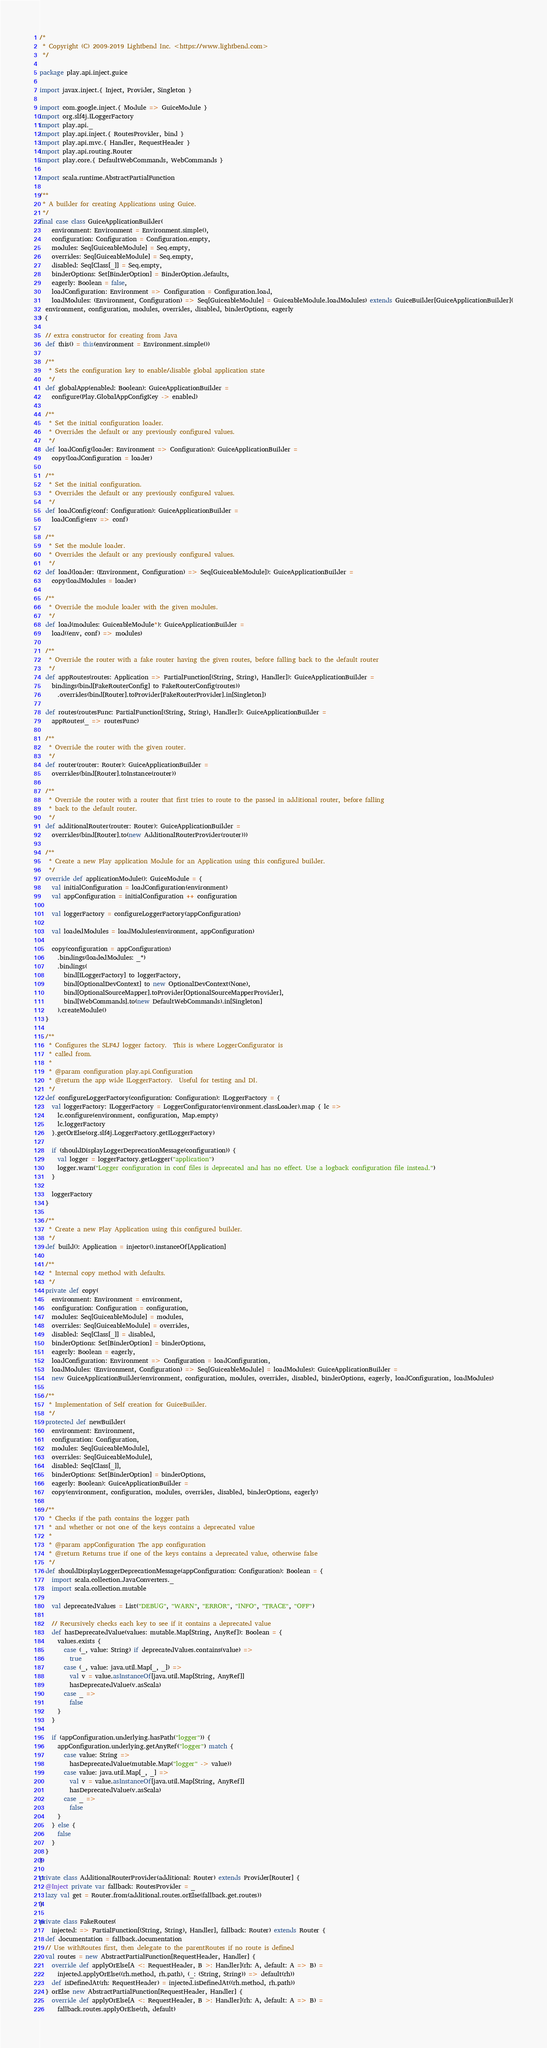Convert code to text. <code><loc_0><loc_0><loc_500><loc_500><_Scala_>/*
 * Copyright (C) 2009-2019 Lightbend Inc. <https://www.lightbend.com>
 */

package play.api.inject.guice

import javax.inject.{ Inject, Provider, Singleton }

import com.google.inject.{ Module => GuiceModule }
import org.slf4j.ILoggerFactory
import play.api._
import play.api.inject.{ RoutesProvider, bind }
import play.api.mvc.{ Handler, RequestHeader }
import play.api.routing.Router
import play.core.{ DefaultWebCommands, WebCommands }

import scala.runtime.AbstractPartialFunction

/**
 * A builder for creating Applications using Guice.
 */
final case class GuiceApplicationBuilder(
    environment: Environment = Environment.simple(),
    configuration: Configuration = Configuration.empty,
    modules: Seq[GuiceableModule] = Seq.empty,
    overrides: Seq[GuiceableModule] = Seq.empty,
    disabled: Seq[Class[_]] = Seq.empty,
    binderOptions: Set[BinderOption] = BinderOption.defaults,
    eagerly: Boolean = false,
    loadConfiguration: Environment => Configuration = Configuration.load,
    loadModules: (Environment, Configuration) => Seq[GuiceableModule] = GuiceableModule.loadModules) extends GuiceBuilder[GuiceApplicationBuilder](
  environment, configuration, modules, overrides, disabled, binderOptions, eagerly
) {

  // extra constructor for creating from Java
  def this() = this(environment = Environment.simple())

  /**
   * Sets the configuration key to enable/disable global application state
   */
  def globalApp(enabled: Boolean): GuiceApplicationBuilder =
    configure(Play.GlobalAppConfigKey -> enabled)

  /**
   * Set the initial configuration loader.
   * Overrides the default or any previously configured values.
   */
  def loadConfig(loader: Environment => Configuration): GuiceApplicationBuilder =
    copy(loadConfiguration = loader)

  /**
   * Set the initial configuration.
   * Overrides the default or any previously configured values.
   */
  def loadConfig(conf: Configuration): GuiceApplicationBuilder =
    loadConfig(env => conf)

  /**
   * Set the module loader.
   * Overrides the default or any previously configured values.
   */
  def load(loader: (Environment, Configuration) => Seq[GuiceableModule]): GuiceApplicationBuilder =
    copy(loadModules = loader)

  /**
   * Override the module loader with the given modules.
   */
  def load(modules: GuiceableModule*): GuiceApplicationBuilder =
    load((env, conf) => modules)

  /**
   * Override the router with a fake router having the given routes, before falling back to the default router
   */
  def appRoutes(routes: Application => PartialFunction[(String, String), Handler]): GuiceApplicationBuilder =
    bindings(bind[FakeRouterConfig] to FakeRouterConfig(routes))
      .overrides(bind[Router].toProvider[FakeRouterProvider].in[Singleton])

  def routes(routesFunc: PartialFunction[(String, String), Handler]): GuiceApplicationBuilder =
    appRoutes(_ => routesFunc)

  /**
   * Override the router with the given router.
   */
  def router(router: Router): GuiceApplicationBuilder =
    overrides(bind[Router].toInstance(router))

  /**
   * Override the router with a router that first tries to route to the passed in additional router, before falling
   * back to the default router.
   */
  def additionalRouter(router: Router): GuiceApplicationBuilder =
    overrides(bind[Router].to(new AdditionalRouterProvider(router)))

  /**
   * Create a new Play application Module for an Application using this configured builder.
   */
  override def applicationModule(): GuiceModule = {
    val initialConfiguration = loadConfiguration(environment)
    val appConfiguration = initialConfiguration ++ configuration

    val loggerFactory = configureLoggerFactory(appConfiguration)

    val loadedModules = loadModules(environment, appConfiguration)

    copy(configuration = appConfiguration)
      .bindings(loadedModules: _*)
      .bindings(
        bind[ILoggerFactory] to loggerFactory,
        bind[OptionalDevContext] to new OptionalDevContext(None),
        bind[OptionalSourceMapper].toProvider[OptionalSourceMapperProvider],
        bind[WebCommands].to(new DefaultWebCommands).in[Singleton]
      ).createModule()
  }

  /**
   * Configures the SLF4J logger factory.  This is where LoggerConfigurator is
   * called from.
   *
   * @param configuration play.api.Configuration
   * @return the app wide ILoggerFactory.  Useful for testing and DI.
   */
  def configureLoggerFactory(configuration: Configuration): ILoggerFactory = {
    val loggerFactory: ILoggerFactory = LoggerConfigurator(environment.classLoader).map { lc =>
      lc.configure(environment, configuration, Map.empty)
      lc.loggerFactory
    }.getOrElse(org.slf4j.LoggerFactory.getILoggerFactory)

    if (shouldDisplayLoggerDeprecationMessage(configuration)) {
      val logger = loggerFactory.getLogger("application")
      logger.warn("Logger configuration in conf files is deprecated and has no effect. Use a logback configuration file instead.")
    }

    loggerFactory
  }

  /**
   * Create a new Play Application using this configured builder.
   */
  def build(): Application = injector().instanceOf[Application]

  /**
   * Internal copy method with defaults.
   */
  private def copy(
    environment: Environment = environment,
    configuration: Configuration = configuration,
    modules: Seq[GuiceableModule] = modules,
    overrides: Seq[GuiceableModule] = overrides,
    disabled: Seq[Class[_]] = disabled,
    binderOptions: Set[BinderOption] = binderOptions,
    eagerly: Boolean = eagerly,
    loadConfiguration: Environment => Configuration = loadConfiguration,
    loadModules: (Environment, Configuration) => Seq[GuiceableModule] = loadModules): GuiceApplicationBuilder =
    new GuiceApplicationBuilder(environment, configuration, modules, overrides, disabled, binderOptions, eagerly, loadConfiguration, loadModules)

  /**
   * Implementation of Self creation for GuiceBuilder.
   */
  protected def newBuilder(
    environment: Environment,
    configuration: Configuration,
    modules: Seq[GuiceableModule],
    overrides: Seq[GuiceableModule],
    disabled: Seq[Class[_]],
    binderOptions: Set[BinderOption] = binderOptions,
    eagerly: Boolean): GuiceApplicationBuilder =
    copy(environment, configuration, modules, overrides, disabled, binderOptions, eagerly)

  /**
   * Checks if the path contains the logger path
   * and whether or not one of the keys contains a deprecated value
   *
   * @param appConfiguration The app configuration
   * @return Returns true if one of the keys contains a deprecated value, otherwise false
   */
  def shouldDisplayLoggerDeprecationMessage(appConfiguration: Configuration): Boolean = {
    import scala.collection.JavaConverters._
    import scala.collection.mutable

    val deprecatedValues = List("DEBUG", "WARN", "ERROR", "INFO", "TRACE", "OFF")

    // Recursively checks each key to see if it contains a deprecated value
    def hasDeprecatedValue(values: mutable.Map[String, AnyRef]): Boolean = {
      values.exists {
        case (_, value: String) if deprecatedValues.contains(value) =>
          true
        case (_, value: java.util.Map[_, _]) =>
          val v = value.asInstanceOf[java.util.Map[String, AnyRef]]
          hasDeprecatedValue(v.asScala)
        case _ =>
          false
      }
    }

    if (appConfiguration.underlying.hasPath("logger")) {
      appConfiguration.underlying.getAnyRef("logger") match {
        case value: String =>
          hasDeprecatedValue(mutable.Map("logger" -> value))
        case value: java.util.Map[_, _] =>
          val v = value.asInstanceOf[java.util.Map[String, AnyRef]]
          hasDeprecatedValue(v.asScala)
        case _ =>
          false
      }
    } else {
      false
    }
  }
}

private class AdditionalRouterProvider(additional: Router) extends Provider[Router] {
  @Inject private var fallback: RoutesProvider = _
  lazy val get = Router.from(additional.routes.orElse(fallback.get.routes))
}

private class FakeRoutes(
    injected: => PartialFunction[(String, String), Handler], fallback: Router) extends Router {
  def documentation = fallback.documentation
  // Use withRoutes first, then delegate to the parentRoutes if no route is defined
  val routes = new AbstractPartialFunction[RequestHeader, Handler] {
    override def applyOrElse[A <: RequestHeader, B >: Handler](rh: A, default: A => B) =
      injected.applyOrElse((rh.method, rh.path), (_: (String, String)) => default(rh))
    def isDefinedAt(rh: RequestHeader) = injected.isDefinedAt((rh.method, rh.path))
  } orElse new AbstractPartialFunction[RequestHeader, Handler] {
    override def applyOrElse[A <: RequestHeader, B >: Handler](rh: A, default: A => B) =
      fallback.routes.applyOrElse(rh, default)</code> 